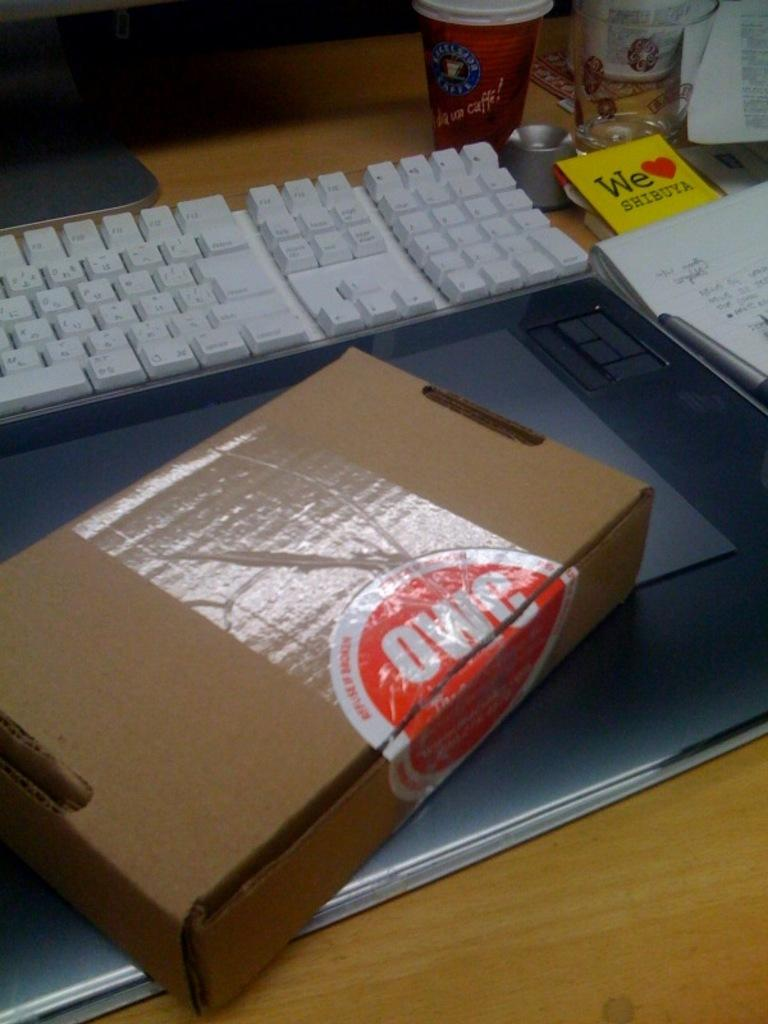<image>
Provide a brief description of the given image. A cardboard box with label "OWC" next to a keyboard. 